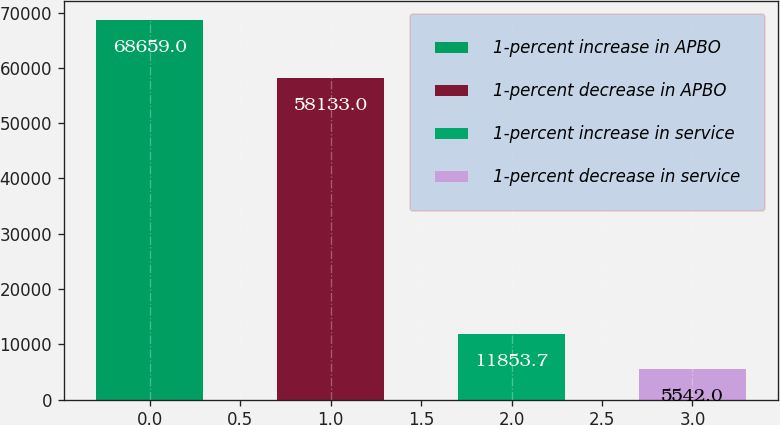<chart> <loc_0><loc_0><loc_500><loc_500><bar_chart><fcel>1-percent increase in APBO<fcel>1-percent decrease in APBO<fcel>1-percent increase in service<fcel>1-percent decrease in service<nl><fcel>68659<fcel>58133<fcel>11853.7<fcel>5542<nl></chart> 